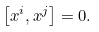<formula> <loc_0><loc_0><loc_500><loc_500>\left [ x ^ { i } , x ^ { j } \right ] = 0 .</formula> 